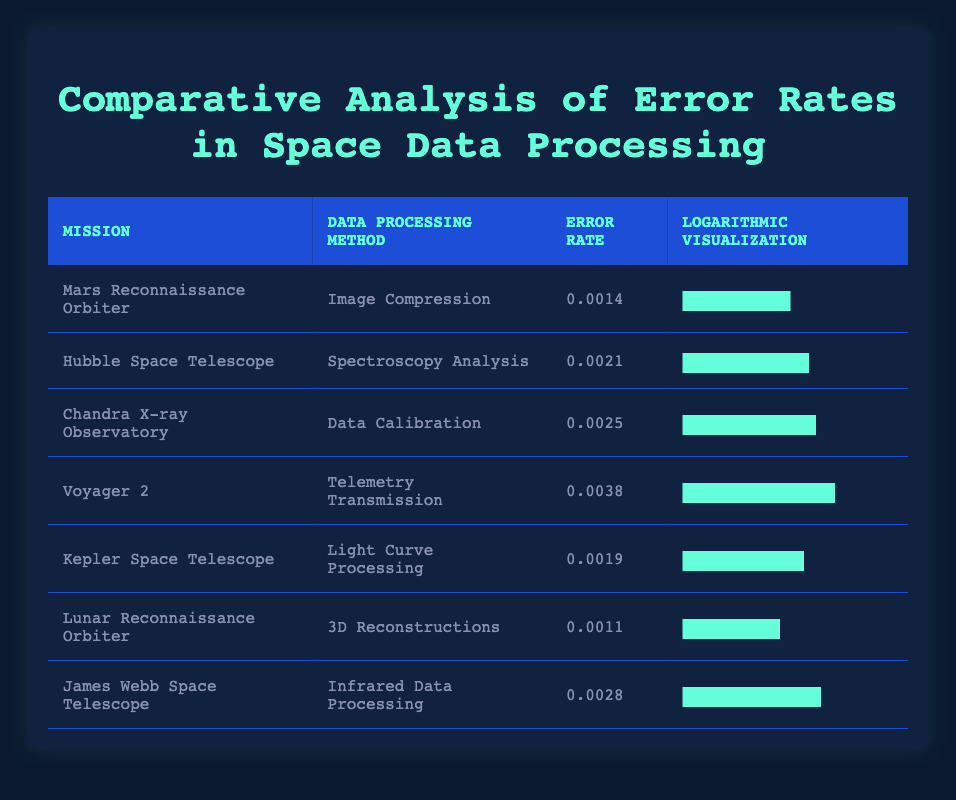What is the error rate for the Mars Reconnaissance Orbiter? The table shows that the error rate for the Mars Reconnaissance Orbiter is listed under the "Error Rate" column, where it is shown as 0.0014.
Answer: 0.0014 Which mission has the highest error rate? By examining the "Error Rate" column, Voyager 2 has the highest error rate at 0.0038, compared to the others in the table.
Answer: Voyager 2 What is the average error rate of all missions listed? To calculate the average error rate, sum all error rates (0.0014 + 0.0021 + 0.0025 + 0.0038 + 0.0019 + 0.0011 + 0.0028 = 0.0156) and divide by the number of missions (7), resulting in an average error rate of 0.0156/7 = 0.002228571.
Answer: 0.00223 Is the error rate for the Lunar Reconnaissance Orbiter less than 0.002? The error rate for the Lunar Reconnaissance Orbiter is 0.0011, which is indeed less than 0.002, making the statement true.
Answer: Yes Which data processing method has a lower error rate, Image Compression or 3D Reconstructions? The table shows that the error rate for Image Compression (0.0014) is higher than that for 3D Reconstructions (0.0011). Therefore, 3D Reconstructions has a lower error rate.
Answer: 3D Reconstructions If the error rates are ordered from highest to lowest, what is the second highest error rate? Sorting the error rates gives: 0.0038 (Voyager 2), 0.0028 (James Webb Space Telescope), followed by 0.0025 (Chandra X-ray Observatory). Thus, the second highest error rate is 0.0028.
Answer: 0.0028 What percentage of missions have an error rate less than 0.0025? The missions with error rates less than 0.0025 are Mars Reconnaissance Orbiter (0.0014), Kepler Space Telescope (0.0019), Lunar Reconnaissance Orbiter (0.0011), and Voyager 2 is excluded. That's 4 out of 7 missions, giving a percentage of (4/7)*100 = 57.14%.
Answer: 57.14% What is the total error rate from all listed missions? To find the total error rate, we add all the error rates: 0.0014 + 0.0021 + 0.0025 + 0.0038 + 0.0019 + 0.0011 + 0.0028 = 0.0156. Therefore, the total error rate is 0.0156.
Answer: 0.0156 